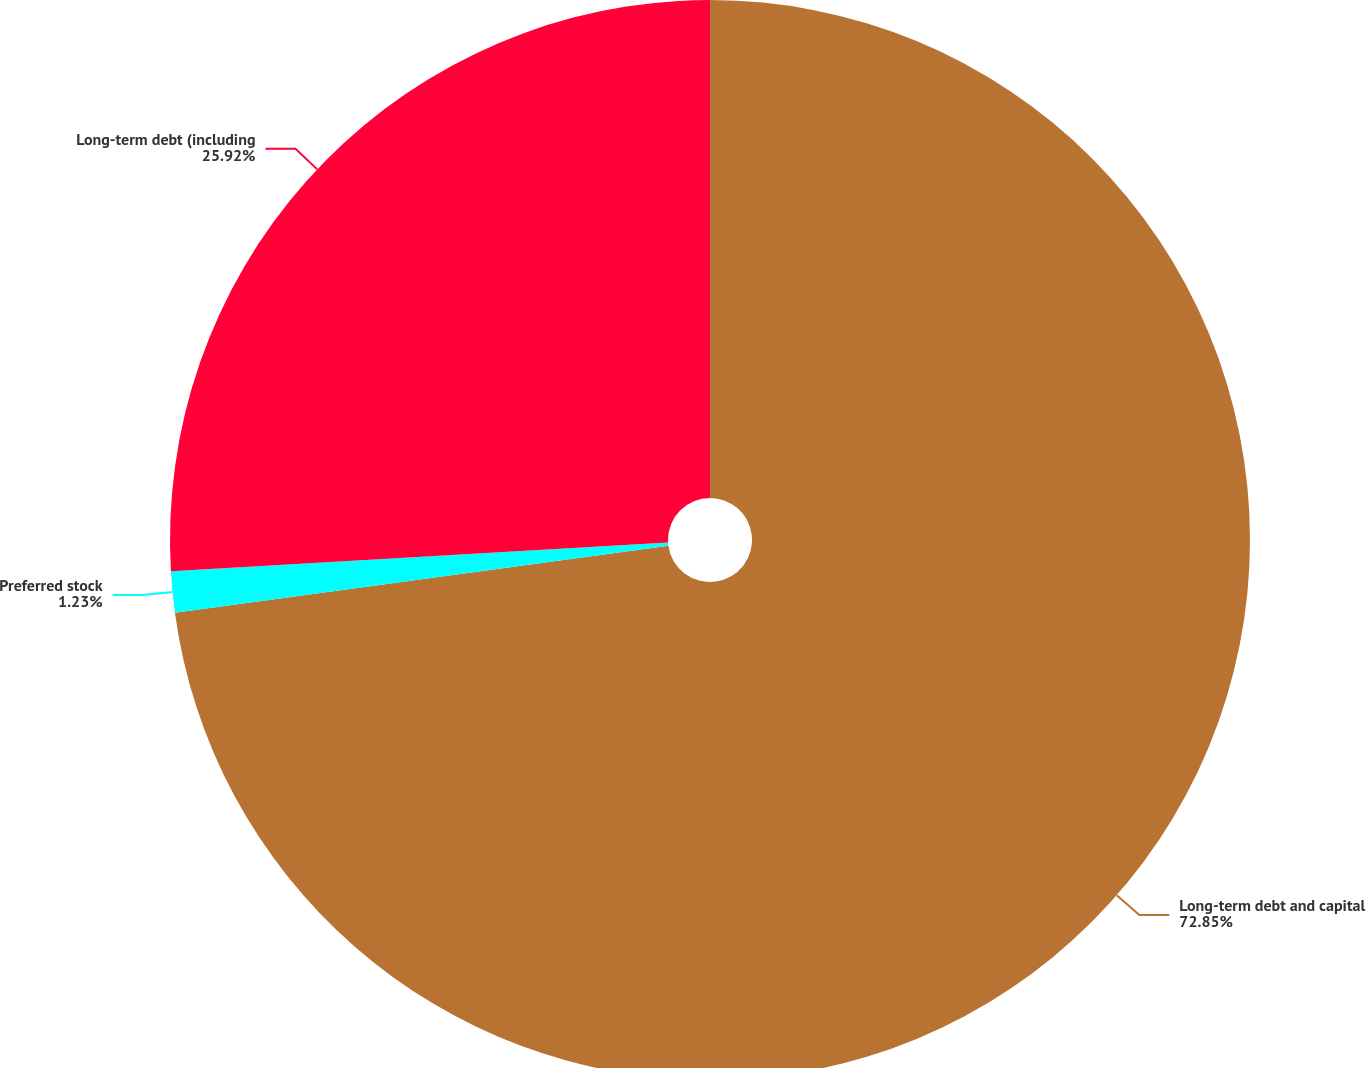Convert chart. <chart><loc_0><loc_0><loc_500><loc_500><pie_chart><fcel>Long-term debt and capital<fcel>Preferred stock<fcel>Long-term debt (including<nl><fcel>72.85%<fcel>1.23%<fcel>25.92%<nl></chart> 